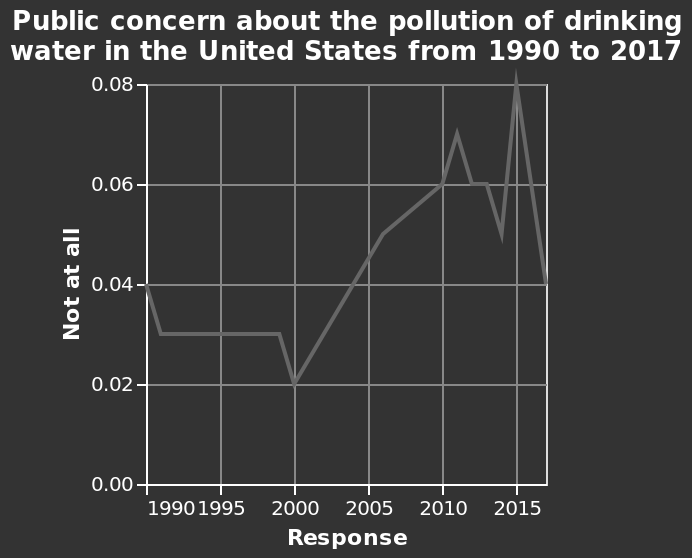<image>
What was the highest level of public concern in 2015? The highest level of public concern in 2015 was about 0.084. Was public concern higher in 2015 or in 1990-2004?  Public concern was higher in 2015. What was the lowest level of public concern between 1990 and 2004?  The lowest level of public concern between 1990 and 2004 was below 0.04. What was the range of public concern between 2005 and 2017? The range of public concern between 2005 and 2017 was between about 0.04 and 0.084. 